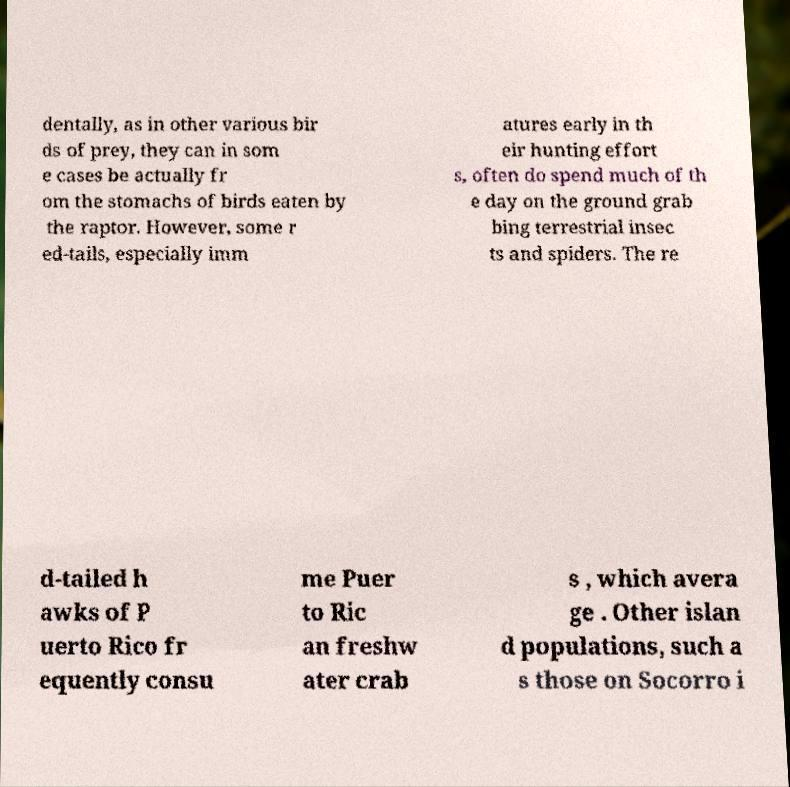For documentation purposes, I need the text within this image transcribed. Could you provide that? dentally, as in other various bir ds of prey, they can in som e cases be actually fr om the stomachs of birds eaten by the raptor. However, some r ed-tails, especially imm atures early in th eir hunting effort s, often do spend much of th e day on the ground grab bing terrestrial insec ts and spiders. The re d-tailed h awks of P uerto Rico fr equently consu me Puer to Ric an freshw ater crab s , which avera ge . Other islan d populations, such a s those on Socorro i 